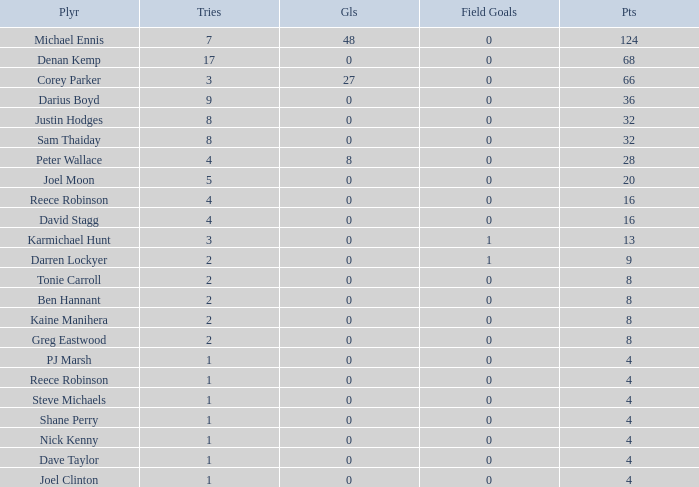What is the total number of field goals of Denan Kemp, who has more than 4 tries, more than 32 points, and 0 goals? 1.0. 